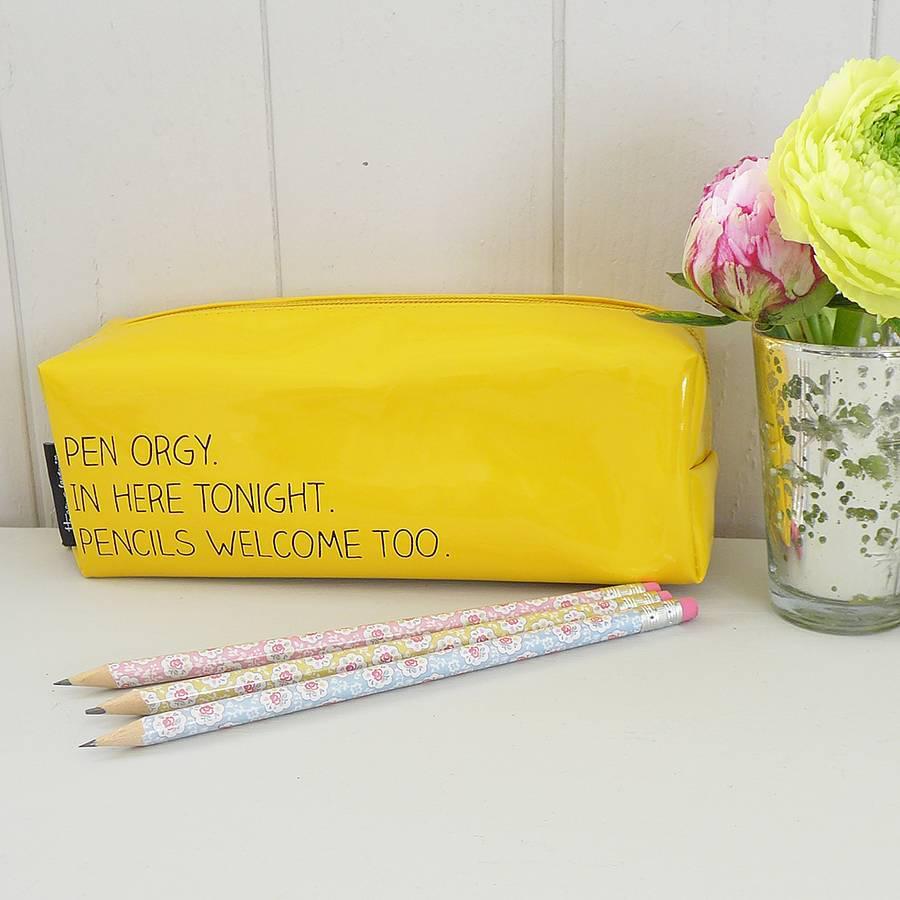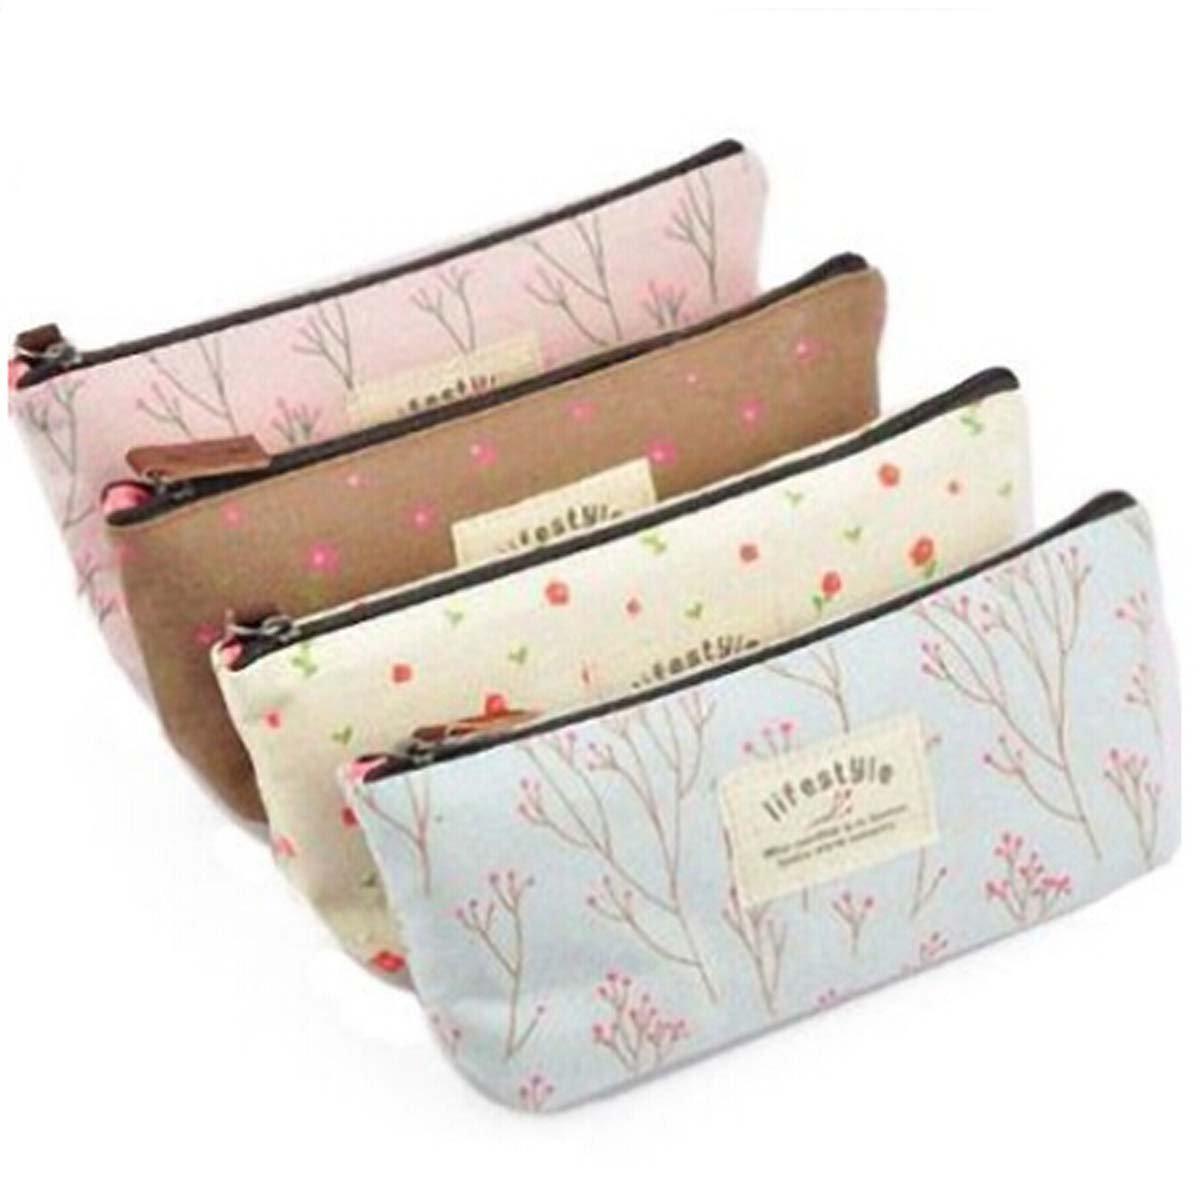The first image is the image on the left, the second image is the image on the right. For the images shown, is this caption "The left image shows one case with at least some contents visible." true? Answer yes or no. No. 